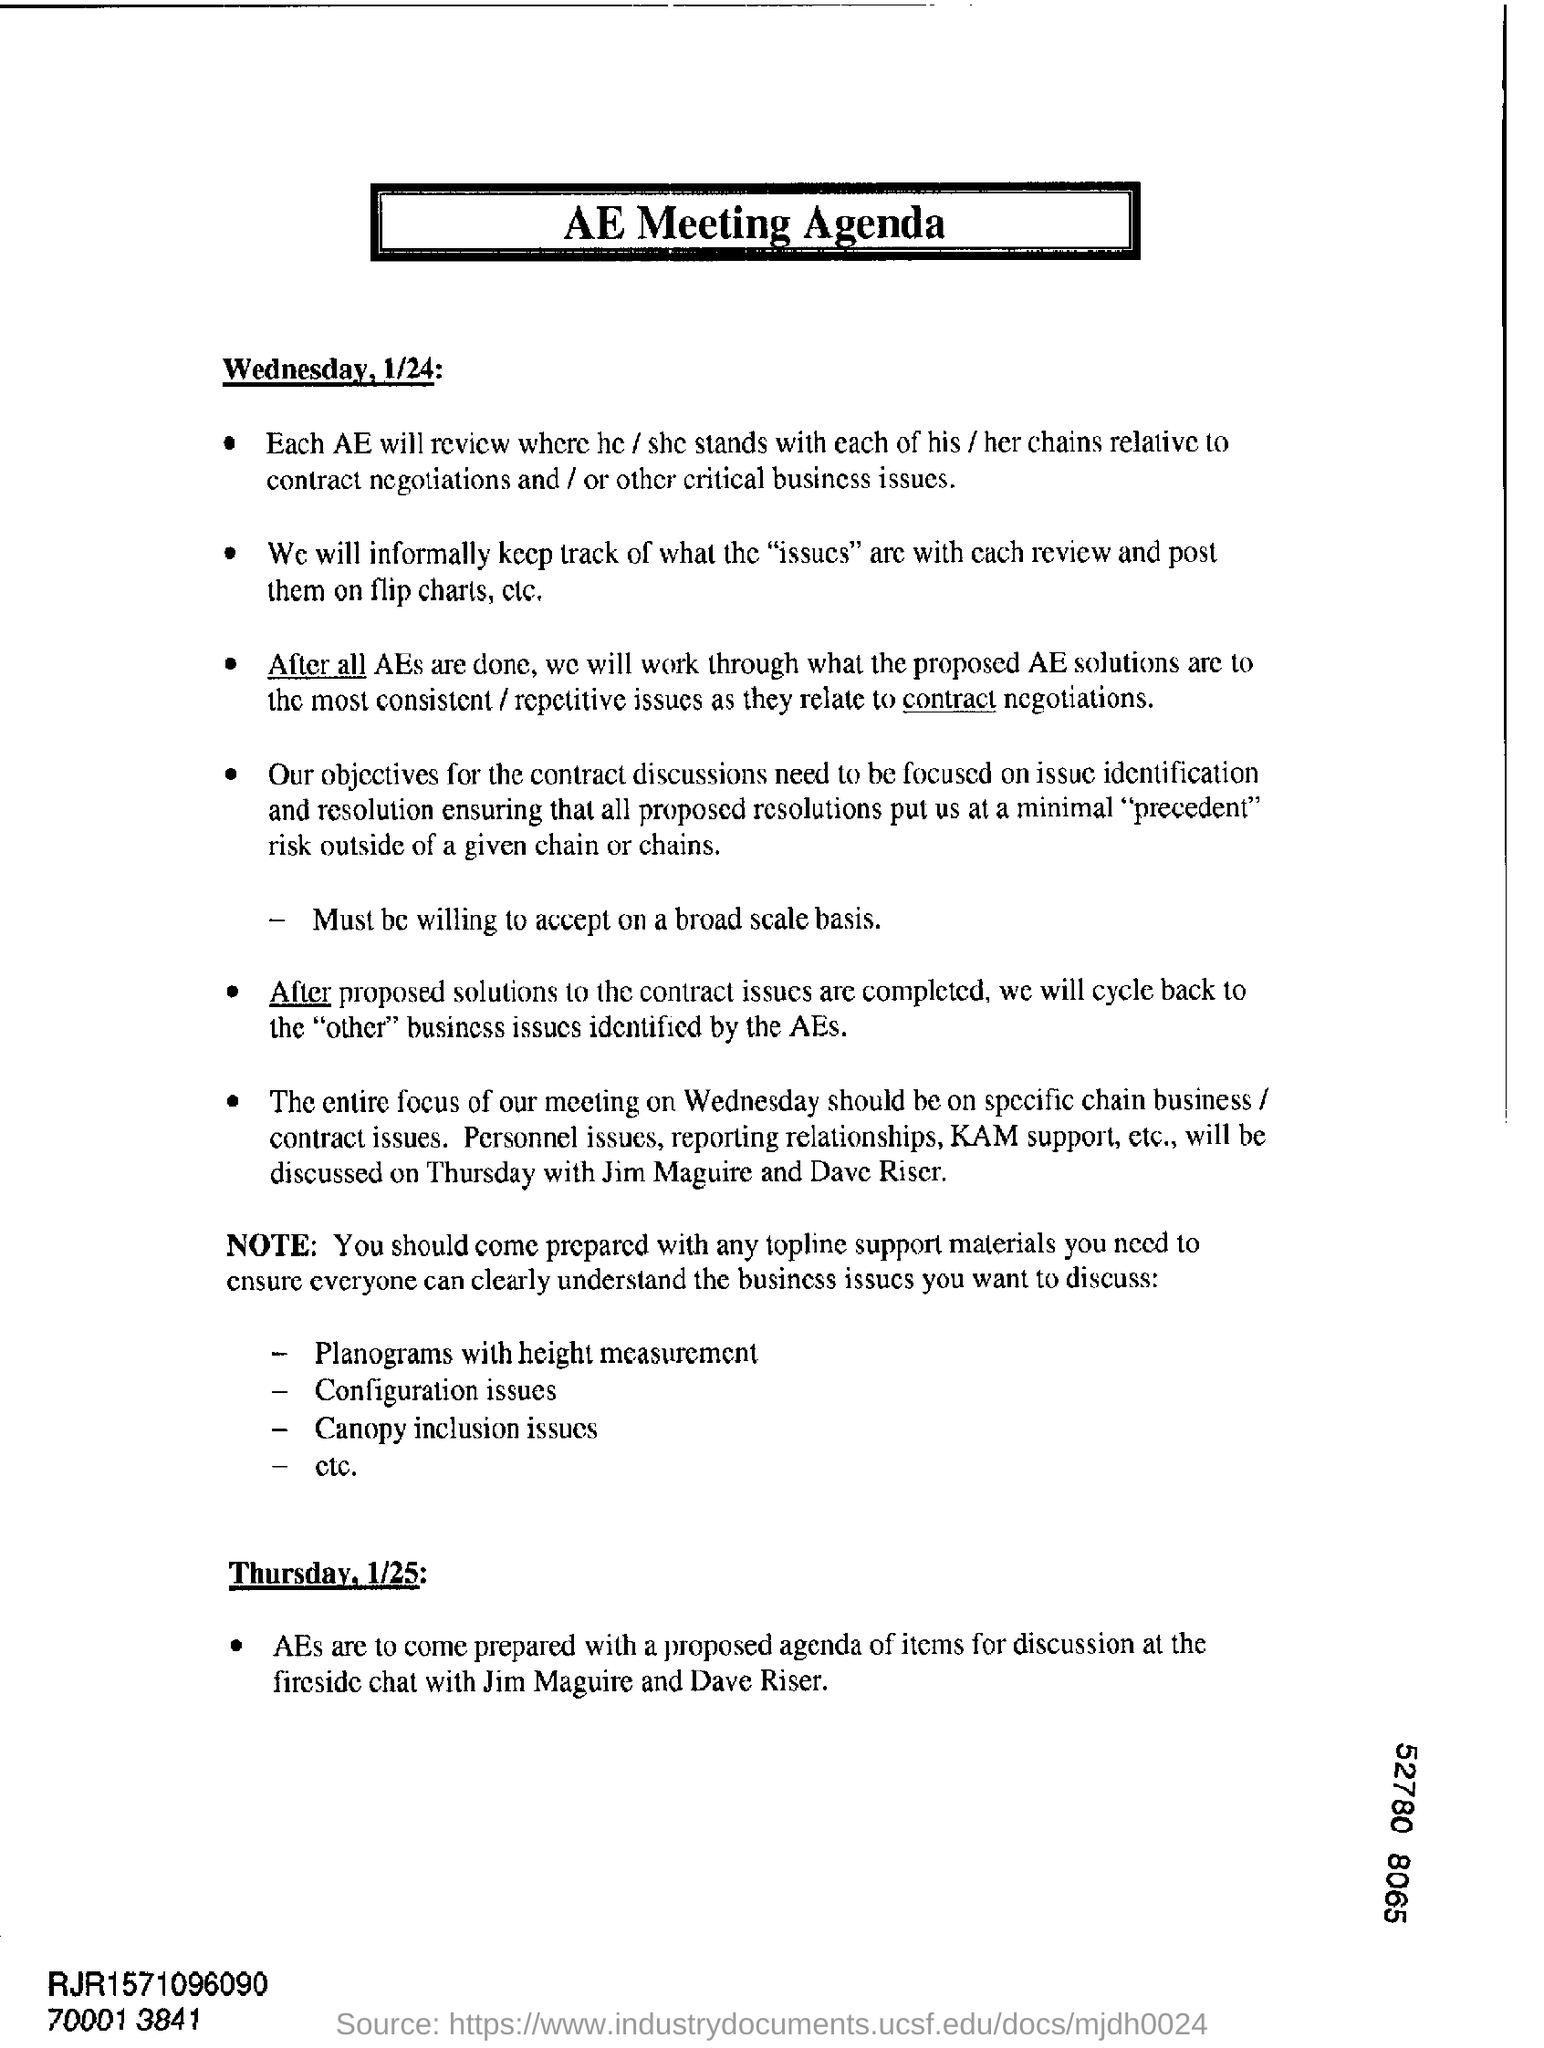This is an AGENDA for which meeting?
Offer a very short reply. AE meeting. What is the first date mentioned?
Your response must be concise. Wednesday, 1/24. 